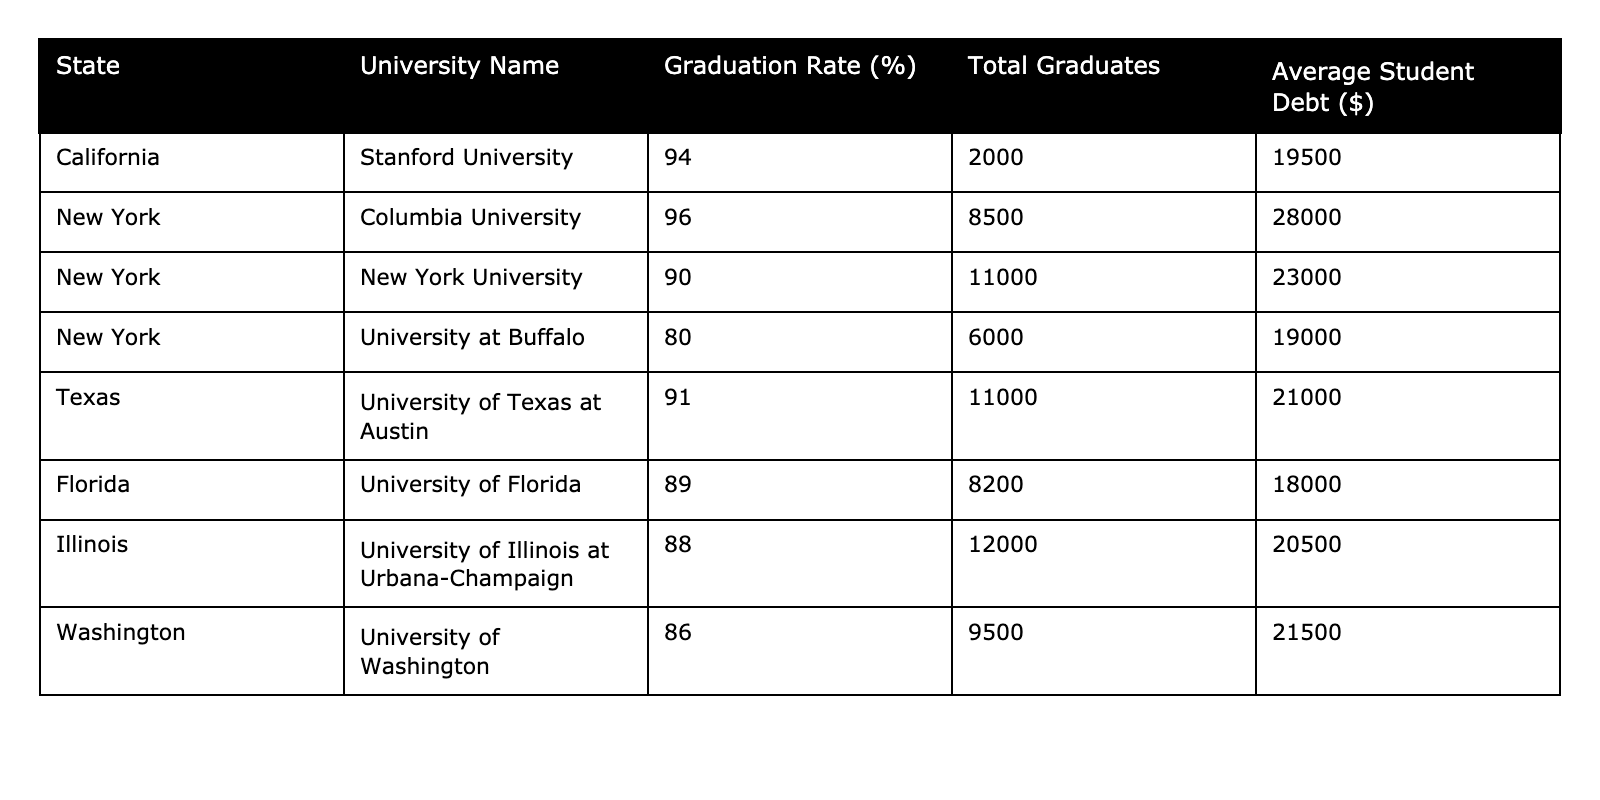What is the graduation rate of Stanford University? The table shows that Stanford University is located in California and has a graduation rate of 94%.
Answer: 94% What is the average student debt for graduates from Columbia University? According to the table, Columbia University, located in New York, has an average student debt of $28,000.
Answer: $28,000 Which university has the lowest graduation rate in the table? By examining the graduation rates listed, the University at Buffalo has the lowest rate at 80%.
Answer: University at Buffalo What is the total number of graduates from New York University and the University at Buffalo combined? New York University has 11,000 graduates, and the University at Buffalo has 6,000 graduates. Adding these gives 11,000 + 6,000 = 17,000 total graduates.
Answer: 17,000 Is the graduation rate of the University of Florida higher than that of the University of Illinois at Urbana-Champaign? The University of Florida has a graduation rate of 89%, while the University of Illinois has a rate of 88%. Since 89% is greater than 88%, the statement is true.
Answer: Yes What is the difference in graduation rates between Columbia University and the University of Washington? Columbia University has a graduation rate of 96%, and the University of Washington has a rate of 86%. The difference is 96% - 86% = 10%.
Answer: 10% Which state has the highest average student debt based on the table? Checking the average student debt values, Columbia University has the highest debt at $28,000, indicating that New York has the highest average student debt among the listed universities.
Answer: New York If you sum up the graduation rates of all the universities listed, what would the total be? The graduation rates are 94, 96, 90, 80, 91, 89, 88, and 86. Summing these yields 94 + 96 + 90 + 80 + 91 + 89 + 88 + 86 = 720.
Answer: 720 Which university has a graduation rate higher than 90% and is located in Texas? The University of Texas at Austin has a graduation rate of 91%, which is higher than 90% and it is located in Texas.
Answer: University of Texas at Austin Are there more total graduates from New York University than from the University of Florida? New York University has 11,000 graduates while the University of Florida has 8,200 graduates. Since 11,000 is greater than 8,200, the answer is yes.
Answer: Yes 